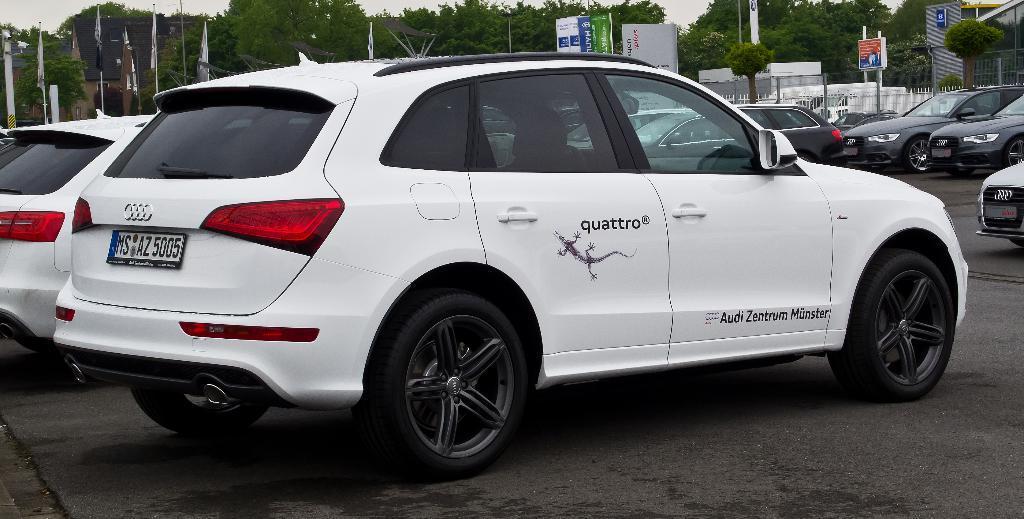In one or two sentences, can you explain what this image depicts? In the middle of the image there are some vehicles. Behind the vehicles there are some poles and trees and flags and banners. 